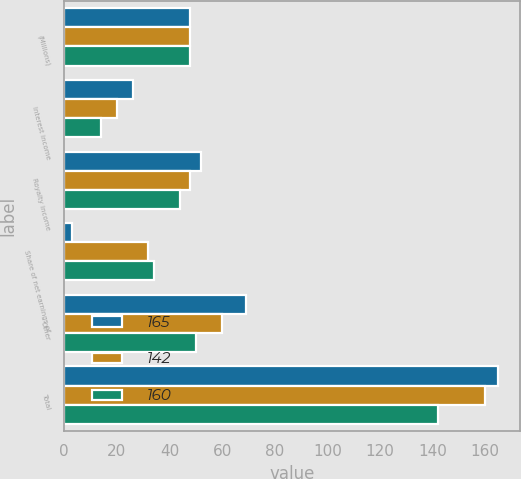Convert chart to OTSL. <chart><loc_0><loc_0><loc_500><loc_500><stacked_bar_chart><ecel><fcel>(Millions)<fcel>Interest income<fcel>Royalty income<fcel>Share of net earnings of<fcel>Other<fcel>Total<nl><fcel>165<fcel>48<fcel>26<fcel>52<fcel>3<fcel>69<fcel>165<nl><fcel>142<fcel>48<fcel>20<fcel>48<fcel>32<fcel>60<fcel>160<nl><fcel>160<fcel>48<fcel>14<fcel>44<fcel>34<fcel>50<fcel>142<nl></chart> 